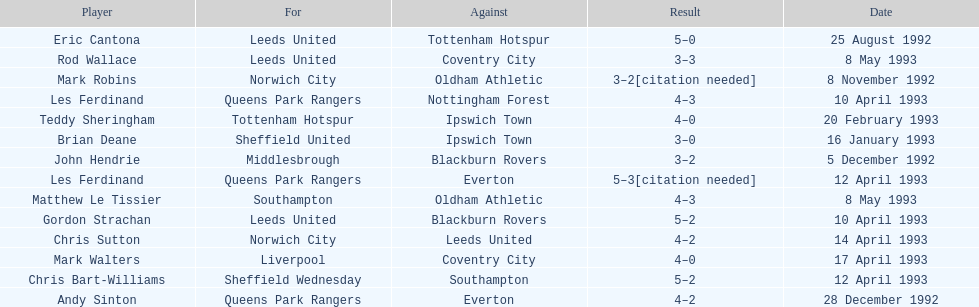Parse the table in full. {'header': ['Player', 'For', 'Against', 'Result', 'Date'], 'rows': [['Eric Cantona', 'Leeds United', 'Tottenham Hotspur', '5–0', '25 August 1992'], ['Rod Wallace', 'Leeds United', 'Coventry City', '3–3', '8 May 1993'], ['Mark Robins', 'Norwich City', 'Oldham Athletic', '3–2[citation needed]', '8 November 1992'], ['Les Ferdinand', 'Queens Park Rangers', 'Nottingham Forest', '4–3', '10 April 1993'], ['Teddy Sheringham', 'Tottenham Hotspur', 'Ipswich Town', '4–0', '20 February 1993'], ['Brian Deane', 'Sheffield United', 'Ipswich Town', '3–0', '16 January 1993'], ['John Hendrie', 'Middlesbrough', 'Blackburn Rovers', '3–2', '5 December 1992'], ['Les Ferdinand', 'Queens Park Rangers', 'Everton', '5–3[citation needed]', '12 April 1993'], ['Matthew Le Tissier', 'Southampton', 'Oldham Athletic', '4–3', '8 May 1993'], ['Gordon Strachan', 'Leeds United', 'Blackburn Rovers', '5–2', '10 April 1993'], ['Chris Sutton', 'Norwich City', 'Leeds United', '4–2', '14 April 1993'], ['Mark Walters', 'Liverpool', 'Coventry City', '4–0', '17 April 1993'], ['Chris Bart-Williams', 'Sheffield Wednesday', 'Southampton', '5–2', '12 April 1993'], ['Andy Sinton', 'Queens Park Rangers', 'Everton', '4–2', '28 December 1992']]} Southampton played on may 8th, 1993, who was their opponent? Oldham Athletic. 